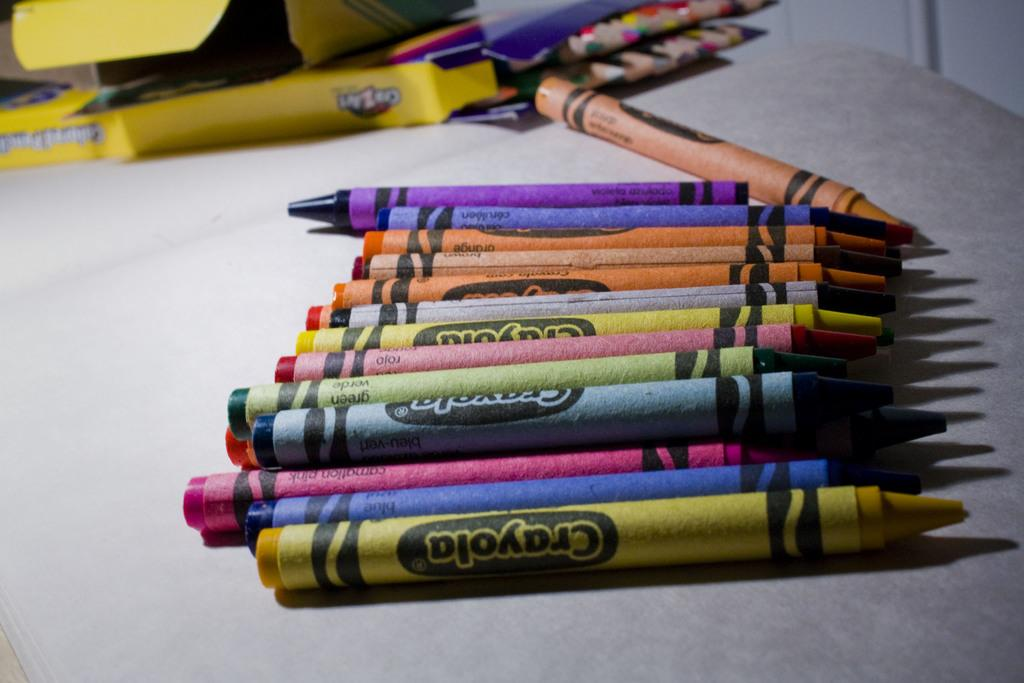<image>
Give a short and clear explanation of the subsequent image. Many colors of crayola crayons are on the table. 